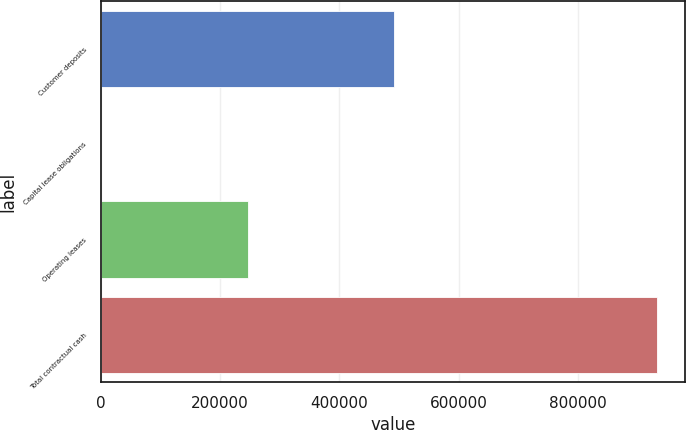<chart> <loc_0><loc_0><loc_500><loc_500><bar_chart><fcel>Customer deposits<fcel>Capital lease obligations<fcel>Operating leases<fcel>Total contractual cash<nl><fcel>492313<fcel>531<fcel>246061<fcel>933086<nl></chart> 